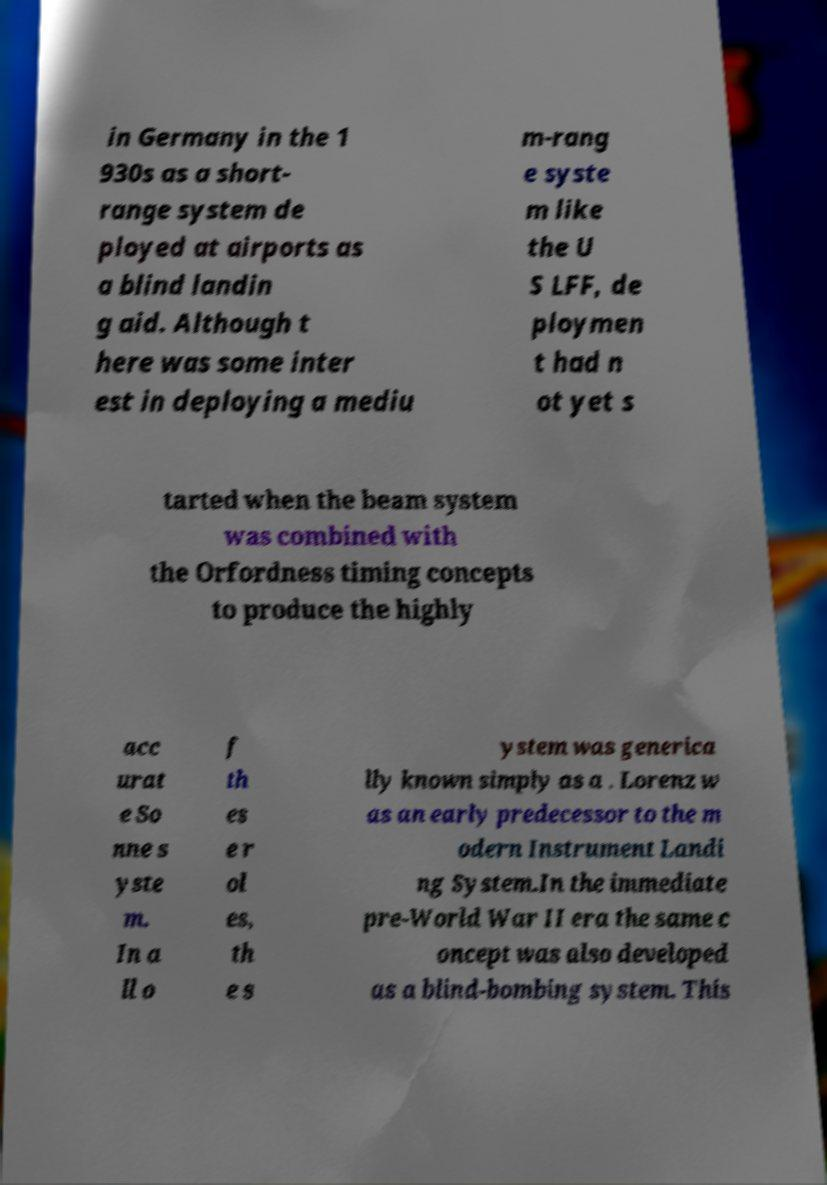Could you assist in decoding the text presented in this image and type it out clearly? in Germany in the 1 930s as a short- range system de ployed at airports as a blind landin g aid. Although t here was some inter est in deploying a mediu m-rang e syste m like the U S LFF, de ploymen t had n ot yet s tarted when the beam system was combined with the Orfordness timing concepts to produce the highly acc urat e So nne s yste m. In a ll o f th es e r ol es, th e s ystem was generica lly known simply as a . Lorenz w as an early predecessor to the m odern Instrument Landi ng System.In the immediate pre-World War II era the same c oncept was also developed as a blind-bombing system. This 